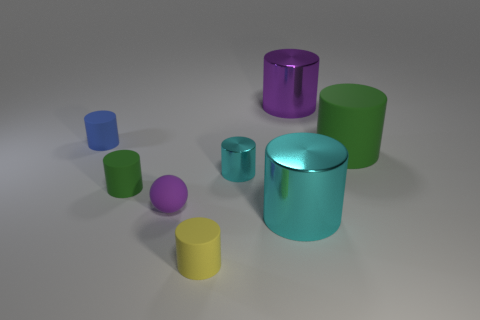There is a thing that is right of the blue matte cylinder and left of the rubber sphere; how big is it?
Offer a terse response. Small. There is a green object that is the same size as the yellow matte object; what is its material?
Your answer should be compact. Rubber. There is a green cylinder that is to the right of the small thing that is in front of the big cyan thing; how many cyan cylinders are in front of it?
Give a very brief answer. 2. There is a big thing behind the small blue object; is its color the same as the ball that is left of the big cyan metal thing?
Your answer should be compact. Yes. What color is the cylinder that is behind the big green rubber cylinder and left of the big purple thing?
Provide a short and direct response. Blue. How many cyan metal cylinders have the same size as the blue object?
Keep it short and to the point. 1. There is a green object that is right of the big shiny cylinder on the left side of the large purple metallic object; what shape is it?
Provide a short and direct response. Cylinder. There is a yellow rubber object in front of the green thing left of the big metal cylinder that is behind the blue rubber cylinder; what shape is it?
Give a very brief answer. Cylinder. What number of large matte objects are the same shape as the small green thing?
Give a very brief answer. 1. What number of purple things are behind the cylinder that is on the right side of the large purple metal thing?
Your answer should be compact. 1. 